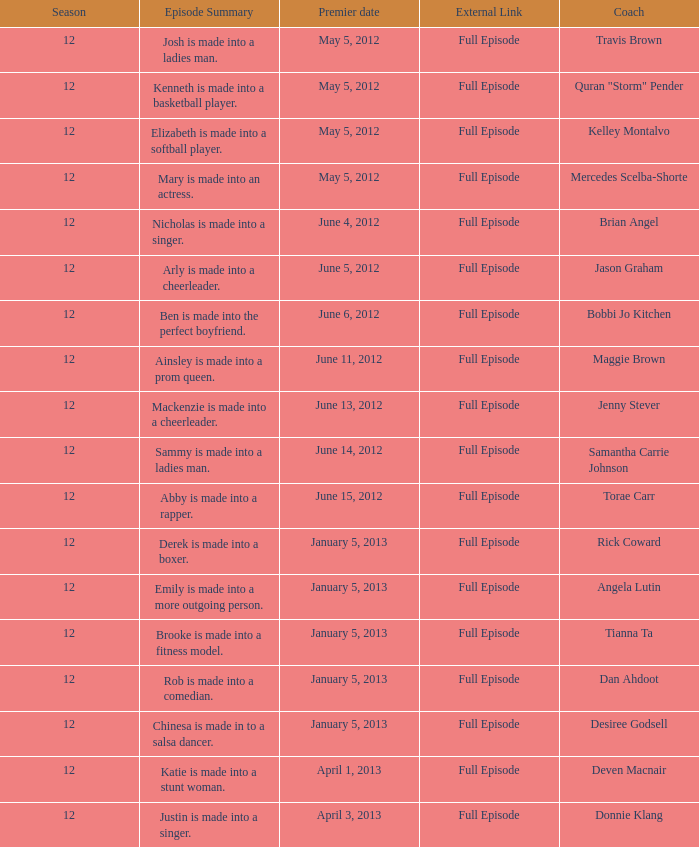Provide the episode description for travis brown. Josh is made into a ladies man. 